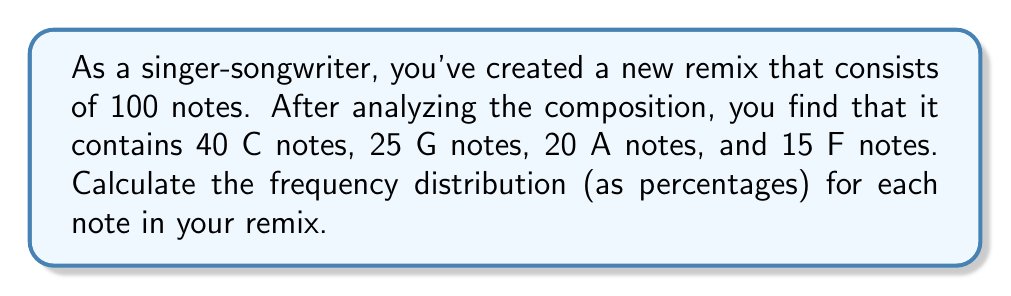Could you help me with this problem? To calculate the frequency distribution of notes in a musical composition, we need to determine the percentage of each note's occurrence in relation to the total number of notes. Let's approach this step-by-step:

1. Identify the total number of notes:
   Total notes = 40 + 25 + 20 + 15 = 100

2. Calculate the frequency (as a percentage) for each note:

   For C notes:
   $$\text{Frequency}_C = \frac{\text{Number of C notes}}{\text{Total notes}} \times 100\% = \frac{40}{100} \times 100\% = 40\%$$

   For G notes:
   $$\text{Frequency}_G = \frac{\text{Number of G notes}}{\text{Total notes}} \times 100\% = \frac{25}{100} \times 100\% = 25\%$$

   For A notes:
   $$\text{Frequency}_A = \frac{\text{Number of A notes}}{\text{Total notes}} \times 100\% = \frac{20}{100} \times 100\% = 20\%$$

   For F notes:
   $$\text{Frequency}_F = \frac{\text{Number of F notes}}{\text{Total notes}} \times 100\% = \frac{15}{100} \times 100\% = 15\%$$

3. Verify that the sum of all frequencies equals 100%:
   40% + 25% + 20% + 15% = 100%

Thus, we have calculated the frequency distribution for each note in the remix.
Answer: C: 40%, G: 25%, A: 20%, F: 15% 